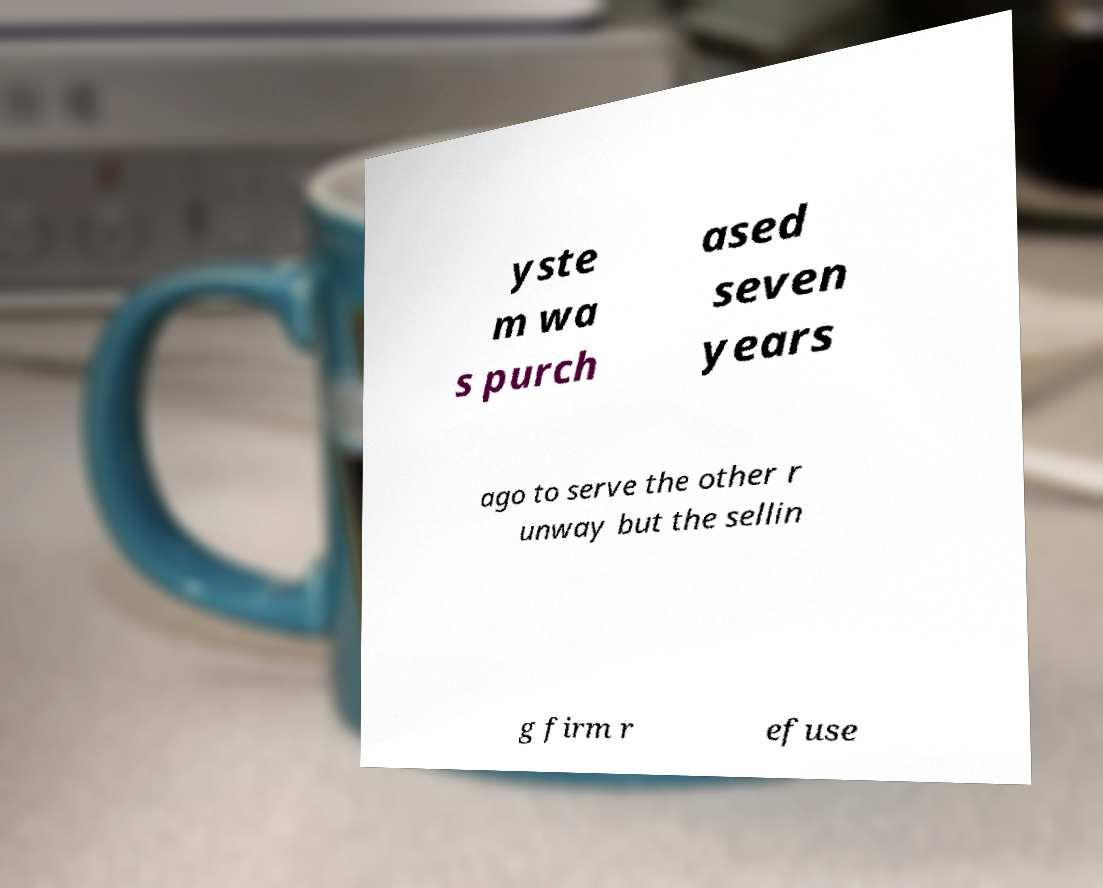What messages or text are displayed in this image? I need them in a readable, typed format. yste m wa s purch ased seven years ago to serve the other r unway but the sellin g firm r efuse 